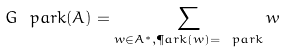<formula> <loc_0><loc_0><loc_500><loc_500>\ G _ { \ } p a r k ( A ) = \sum _ { w \in A ^ { * } , \P a r k ( w ) = \ p a r k } w</formula> 